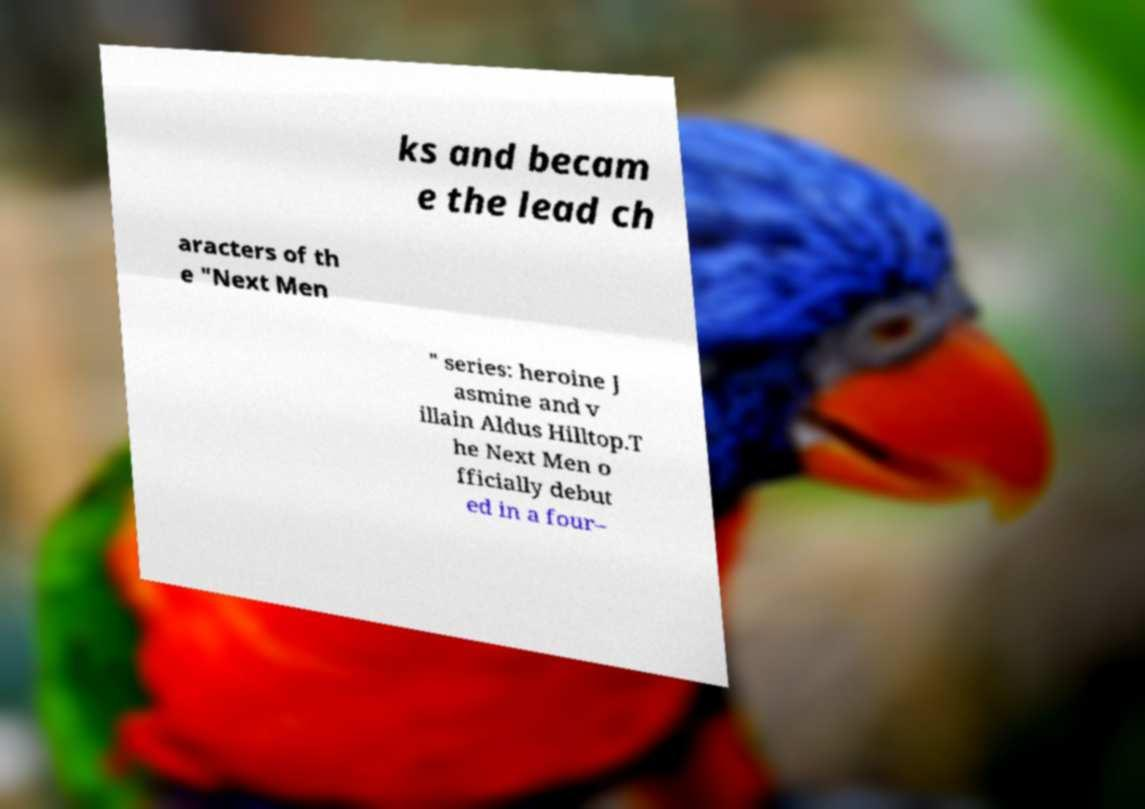I need the written content from this picture converted into text. Can you do that? ks and becam e the lead ch aracters of th e "Next Men " series: heroine J asmine and v illain Aldus Hilltop.T he Next Men o fficially debut ed in a four– 